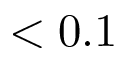<formula> <loc_0><loc_0><loc_500><loc_500>< 0 . 1</formula> 